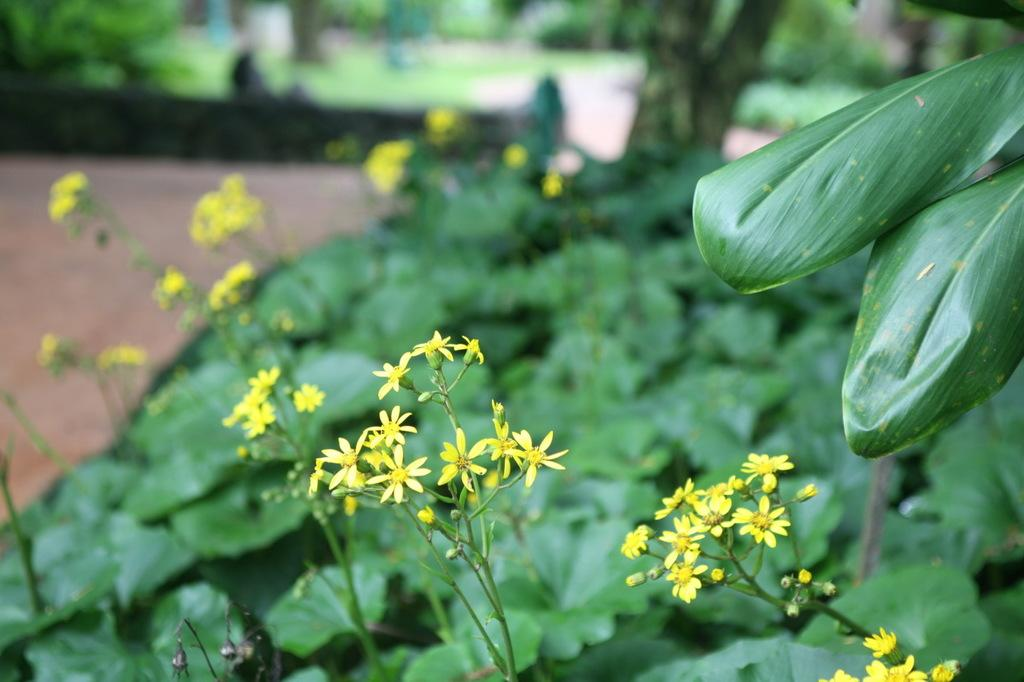What types of vegetation can be seen in the front of the image? There are plants and flowers in the front of the image. What can be seen in the background of the image? There is a tree and grass in the background of the image. How does the background appear in the image? The background appears blurry. What type of oatmeal is being served in the image? There is no oatmeal present in the image; it features plants, flowers, a tree, and grass. 